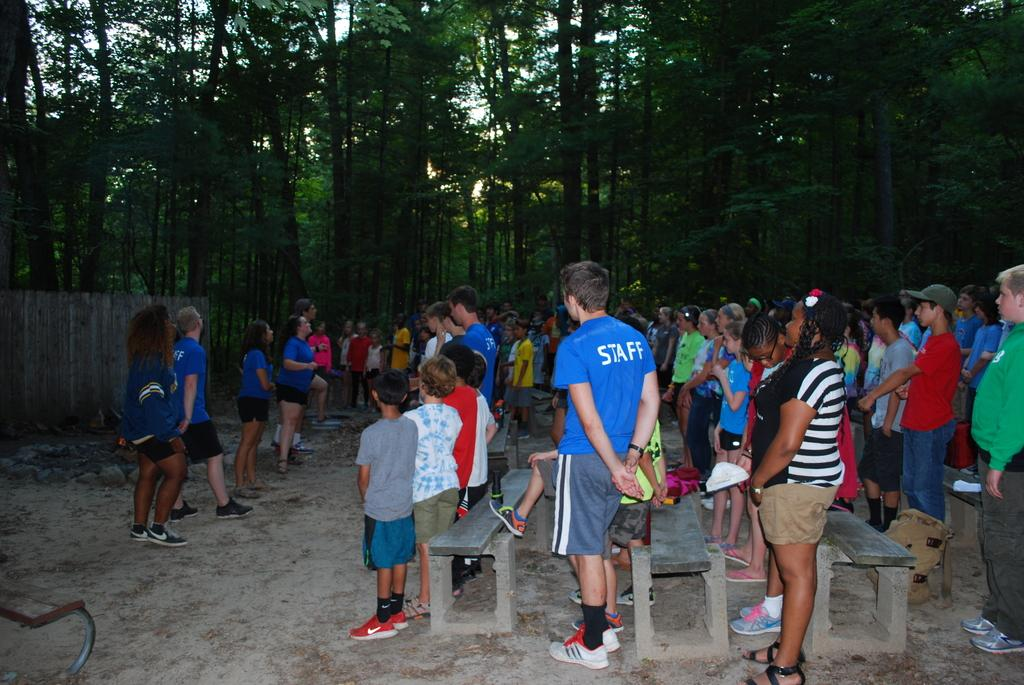What is happening in the image? There is a group of people standing in the image. Where are the people standing? The people are standing on the floor. What can be seen in the foreground of the image? There are benches visible in the foreground of the image. What is visible in the background of the image? Trees are visible at the top of the image. How many bulbs are hanging from the trees in the image? There are no bulbs visible in the image; only trees are present in the background. 